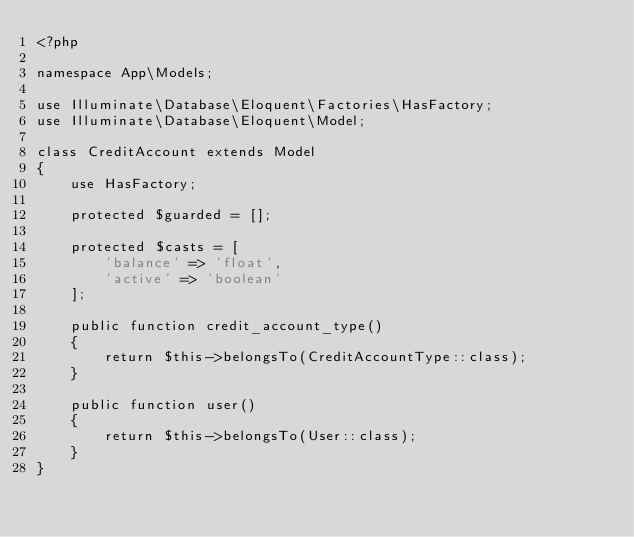<code> <loc_0><loc_0><loc_500><loc_500><_PHP_><?php

namespace App\Models;

use Illuminate\Database\Eloquent\Factories\HasFactory;
use Illuminate\Database\Eloquent\Model;

class CreditAccount extends Model
{
    use HasFactory;

    protected $guarded = [];

    protected $casts = [
        'balance' => 'float',
        'active' => 'boolean'
    ];

    public function credit_account_type()
    {
        return $this->belongsTo(CreditAccountType::class);
    }

    public function user()
    {
        return $this->belongsTo(User::class);
    }
}
</code> 